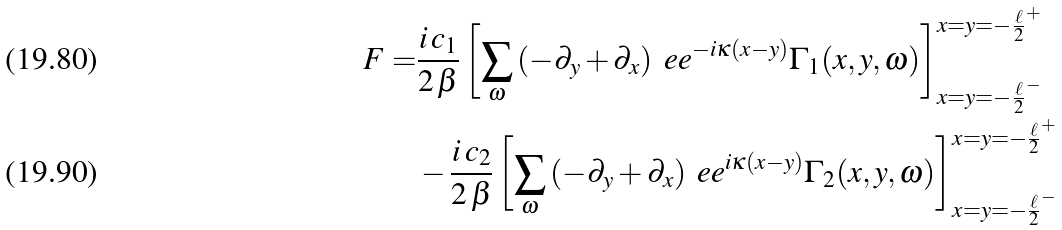<formula> <loc_0><loc_0><loc_500><loc_500>F = & \frac { i \, c _ { 1 } } { 2 \, \beta } \left [ \sum _ { \omega } \left ( - \partial _ { y } + \partial _ { x } \right ) \ e e ^ { - i \kappa ( x - y ) } \Gamma _ { 1 } ( x , y , \omega ) \right ] ^ { x = y = - \frac { \ell } { 2 } ^ { + } } _ { x = y = - \frac { \ell } { 2 } ^ { - } } \\ & - \frac { i \, c _ { 2 } } { 2 \, \beta } \left [ \sum _ { \omega } \left ( - \partial _ { y } + \partial _ { x } \right ) \ e e ^ { i \kappa ( x - y ) } \Gamma _ { 2 } ( x , y , \omega ) \right ] ^ { x = y = - \frac { \ell } { 2 } ^ { + } } _ { x = y = - \frac { \ell } { 2 } ^ { - } }</formula> 